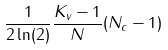Convert formula to latex. <formula><loc_0><loc_0><loc_500><loc_500>\frac { 1 } { 2 \ln ( 2 ) } \frac { K _ { v } - 1 } { N } ( N _ { c } - 1 )</formula> 